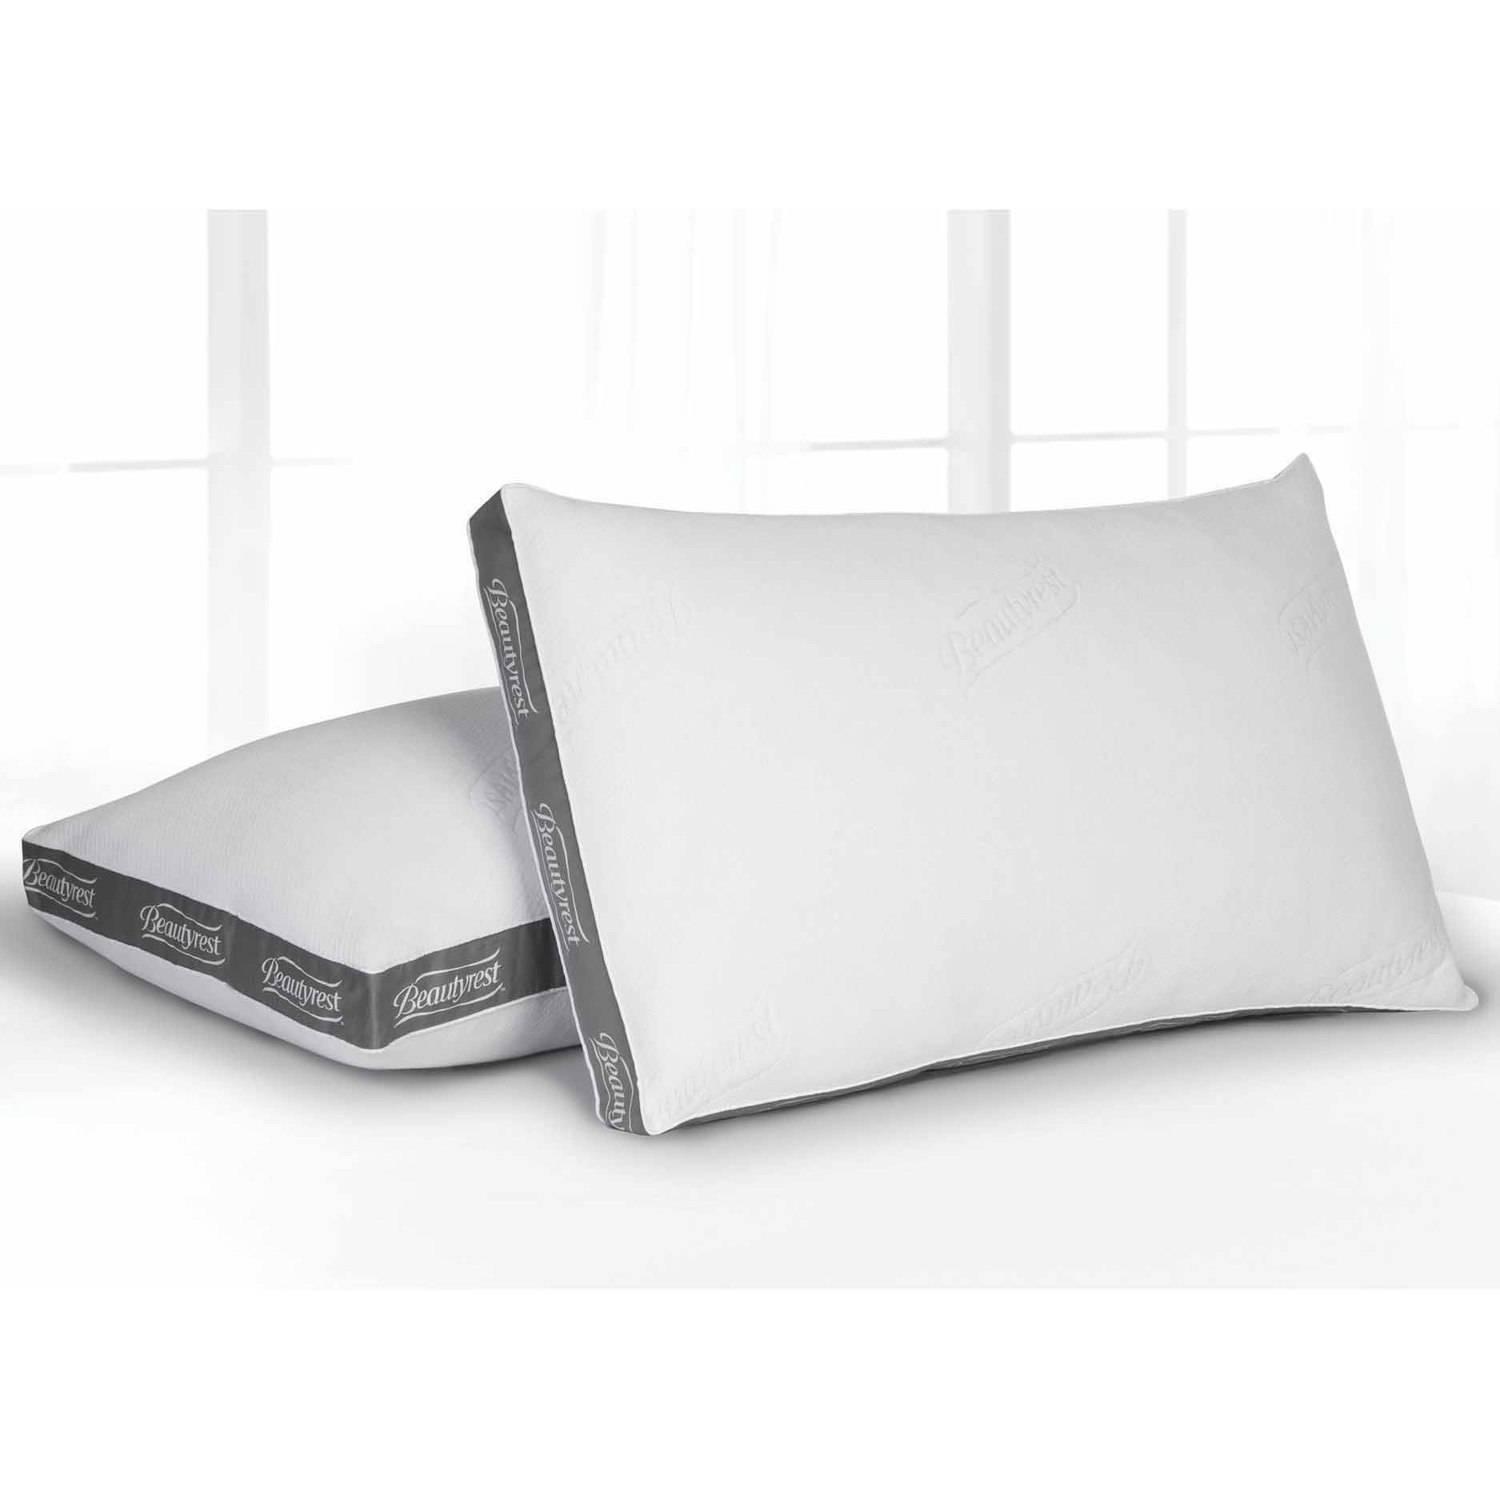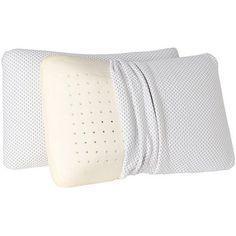The first image is the image on the left, the second image is the image on the right. Evaluate the accuracy of this statement regarding the images: "Two pillows are leaning against each other in the image on the right.". Is it true? Answer yes or no. Yes. The first image is the image on the left, the second image is the image on the right. Evaluate the accuracy of this statement regarding the images: "An image includes a sculpted pillow with a depression for the sleeper's neck.". Is it true? Answer yes or no. No. 